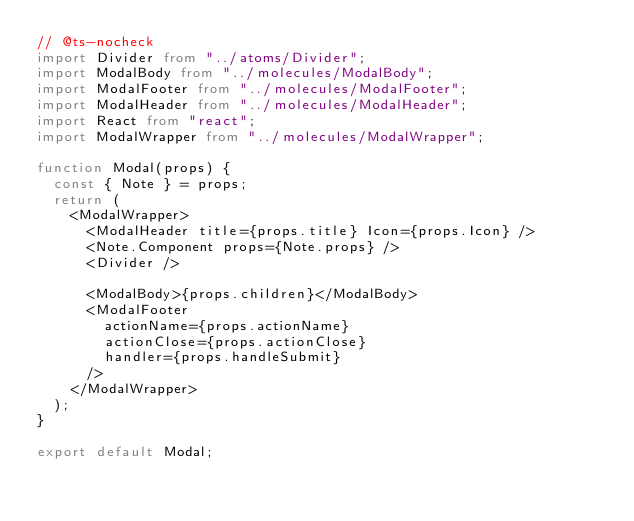<code> <loc_0><loc_0><loc_500><loc_500><_TypeScript_>// @ts-nocheck
import Divider from "../atoms/Divider";
import ModalBody from "../molecules/ModalBody";
import ModalFooter from "../molecules/ModalFooter";
import ModalHeader from "../molecules/ModalHeader";
import React from "react";
import ModalWrapper from "../molecules/ModalWrapper";

function Modal(props) {
  const { Note } = props;
  return (
    <ModalWrapper>
      <ModalHeader title={props.title} Icon={props.Icon} />
      <Note.Component props={Note.props} />
      <Divider />

      <ModalBody>{props.children}</ModalBody>
      <ModalFooter
        actionName={props.actionName}
        actionClose={props.actionClose}
        handler={props.handleSubmit}
      />
    </ModalWrapper>
  );
}

export default Modal;
</code> 